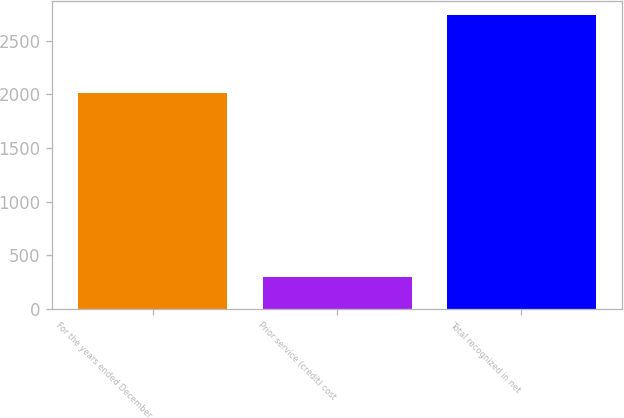<chart> <loc_0><loc_0><loc_500><loc_500><bar_chart><fcel>For the years ended December<fcel>Prior service (credit) cost<fcel>Total recognized in net<nl><fcel>2010<fcel>293<fcel>2736<nl></chart> 